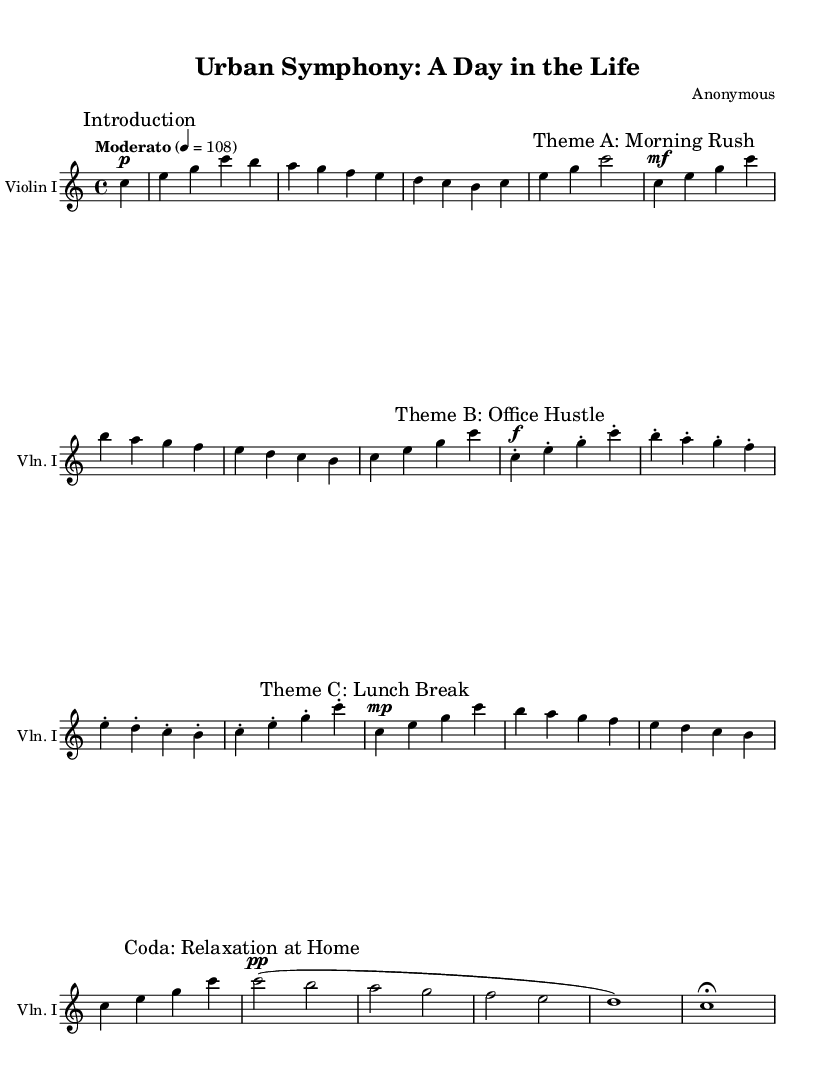What is the key signature of this music? The key signature is C major, which has no sharps or flats indicated in the music sheet.
Answer: C major What is the time signature of this music? The time signature appears as a 4 over 4 in the music sheet, which indicates four beats per measure.
Answer: 4/4 What is the tempo marking provided in the music? The tempo is marked as "Moderato" with a metronome marking of 108 beats per minute, found at the beginning of the score.
Answer: Moderato, 108 What is the dynamic level for "Theme A: Morning Rush"? The dynamic marking for "Theme A" is mezzo-forte, indicated by the marking 'mf' before the first note of that theme.
Answer: mf Which theme represents a "Lunch Break"? The section titled "Theme C: Lunch Break" explicitly states the context of this theme in its marking.
Answer: Theme C: Lunch Break How does the music convey the idea of "Relaxation at Home" in the Coda? The Coda section uses a softer dynamic marking of pianissimo, indicated by 'pp', suggesting a calm and relaxing atmosphere.
Answer: Relaxation at Home 